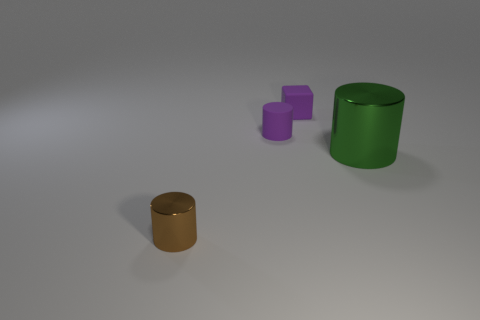What size is the other shiny thing that is the same shape as the green metal object?
Offer a terse response. Small. Does the rubber cylinder have the same color as the small thing that is behind the tiny purple cylinder?
Provide a short and direct response. Yes. There is a rubber thing that is the same shape as the small brown metal object; what is its color?
Your response must be concise. Purple. Do the large green thing and the tiny brown object have the same shape?
Offer a terse response. Yes. Does the small matte thing that is in front of the purple rubber cube have the same color as the matte cube that is to the left of the big cylinder?
Offer a very short reply. Yes. There is a green cylinder; what number of small cylinders are in front of it?
Your answer should be compact. 1. How many matte cubes are the same color as the large metal cylinder?
Your answer should be compact. 0. Is the tiny cylinder that is on the right side of the tiny brown cylinder made of the same material as the small brown cylinder?
Your answer should be very brief. No. What number of other purple blocks have the same material as the cube?
Your answer should be compact. 0. Is the number of purple matte cylinders behind the large green shiny cylinder greater than the number of large red spheres?
Your response must be concise. Yes. 